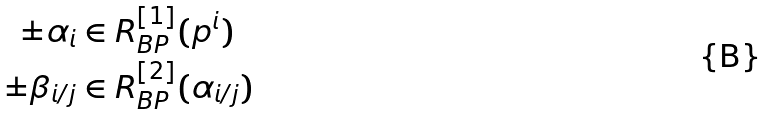<formula> <loc_0><loc_0><loc_500><loc_500>\pm \alpha _ { i } & \in R _ { B P } ^ { [ 1 ] } ( p ^ { i } ) \\ \pm \beta _ { i / j } & \in R _ { B P } ^ { [ 2 ] } ( \alpha _ { i / j } )</formula> 